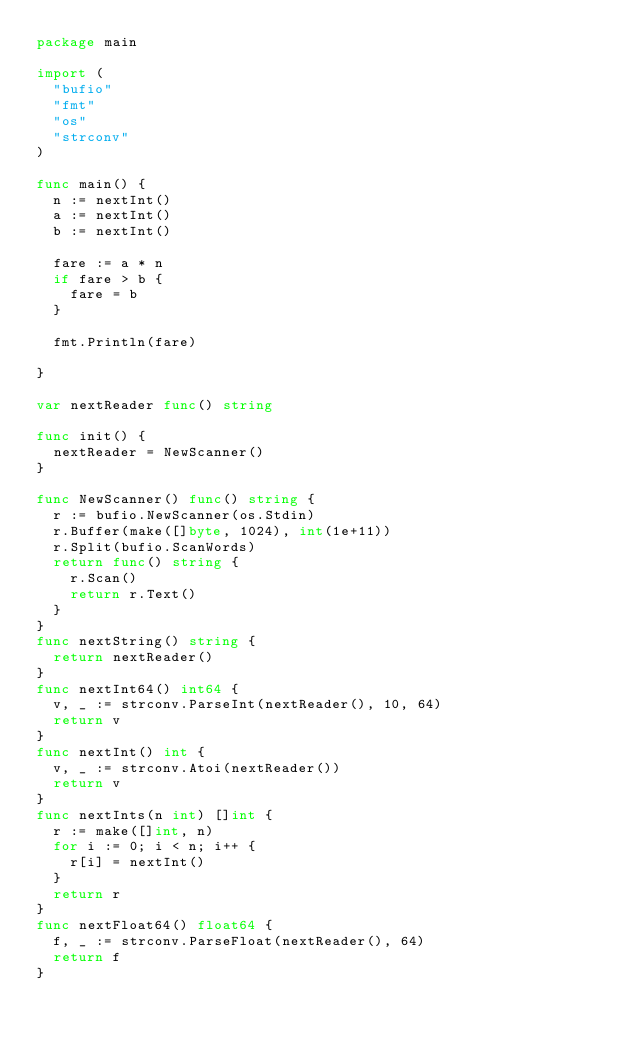Convert code to text. <code><loc_0><loc_0><loc_500><loc_500><_Go_>package main

import (
	"bufio"
	"fmt"
	"os"
	"strconv"
)

func main() {
	n := nextInt()
	a := nextInt()
	b := nextInt()

	fare := a * n
	if fare > b {
		fare = b
	}

	fmt.Println(fare)

}

var nextReader func() string

func init() {
	nextReader = NewScanner()
}

func NewScanner() func() string {
	r := bufio.NewScanner(os.Stdin)
	r.Buffer(make([]byte, 1024), int(1e+11))
	r.Split(bufio.ScanWords)
	return func() string {
		r.Scan()
		return r.Text()
	}
}
func nextString() string {
	return nextReader()
}
func nextInt64() int64 {
	v, _ := strconv.ParseInt(nextReader(), 10, 64)
	return v
}
func nextInt() int {
	v, _ := strconv.Atoi(nextReader())
	return v
}
func nextInts(n int) []int {
	r := make([]int, n)
	for i := 0; i < n; i++ {
		r[i] = nextInt()
	}
	return r
}
func nextFloat64() float64 {
	f, _ := strconv.ParseFloat(nextReader(), 64)
	return f
}</code> 